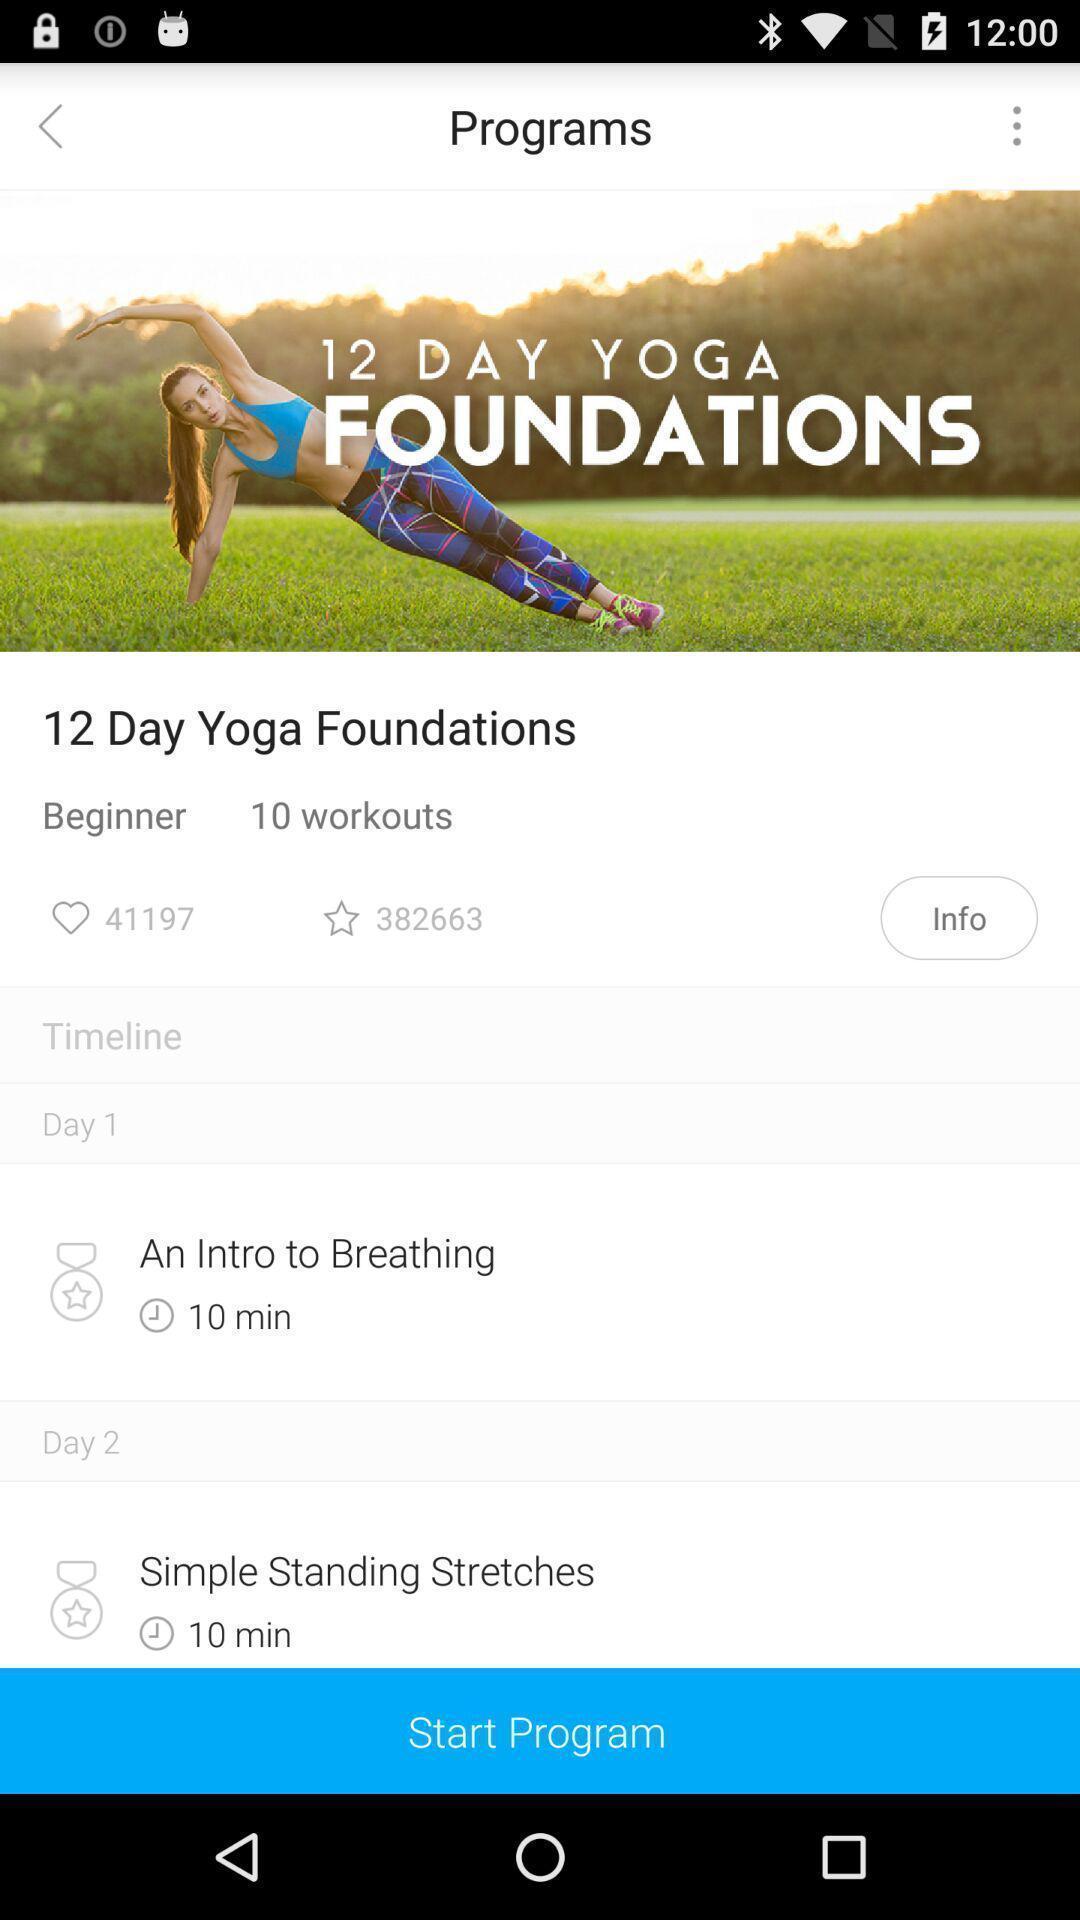Provide a detailed account of this screenshot. Screen displaying multiple workout information. 